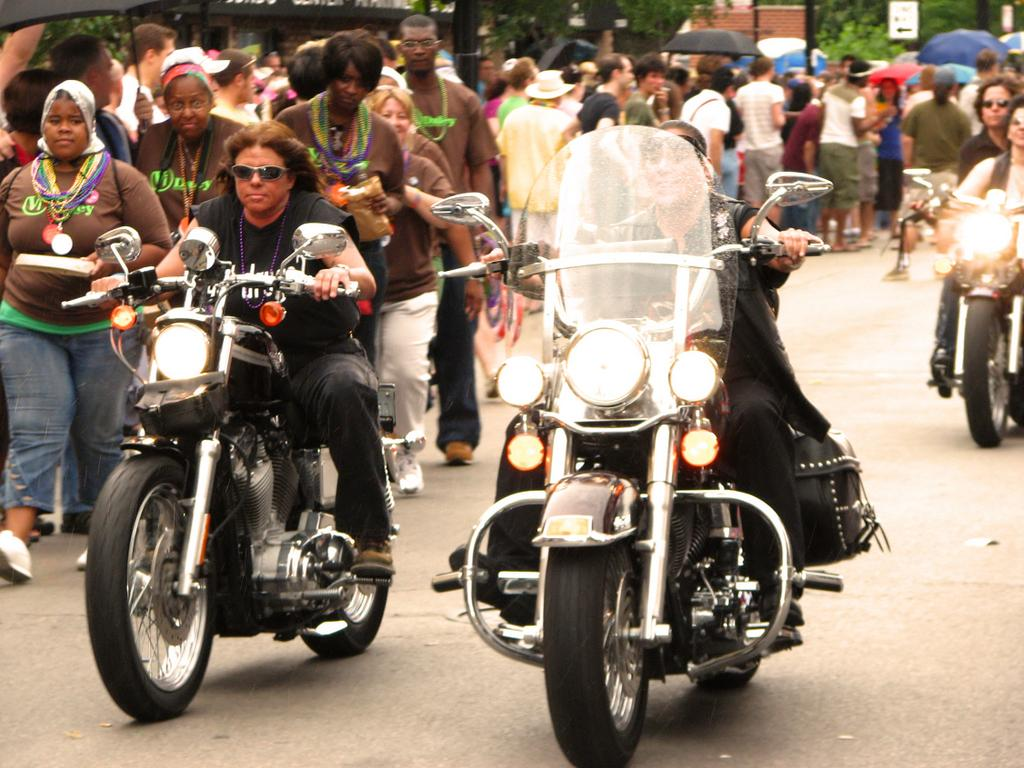What are the three people on motorbikes doing in the image? The three people are riding motorbikes in the image. What are the other people in the image doing? There is a group of people walking, and some people are standing. Are there any people using any protective items in the image? Yes, some people are holding umbrellas in the image. What can be seen in the background of the image? There is a building and trees in the background of the image. What is the distribution of afternoon tea in the image? There is no mention of afternoon tea in the image, so it cannot be determined how it is distributed. 